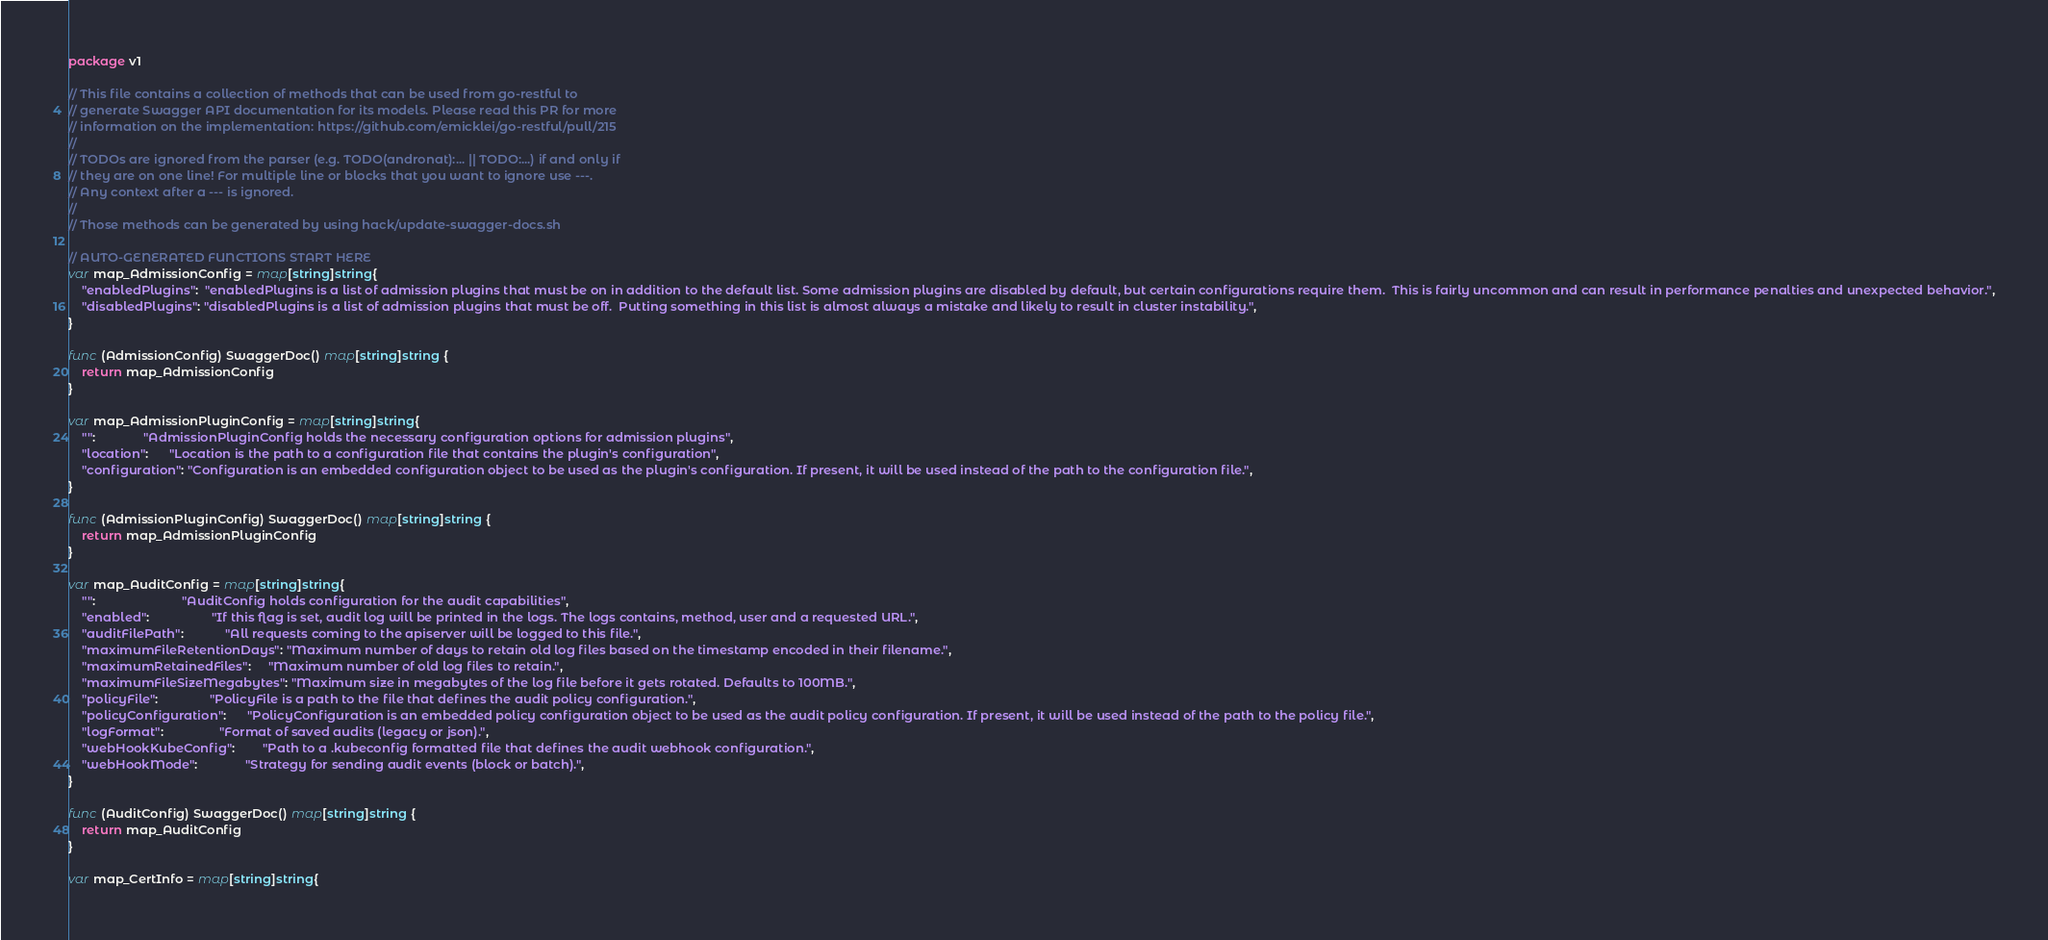<code> <loc_0><loc_0><loc_500><loc_500><_Go_>package v1

// This file contains a collection of methods that can be used from go-restful to
// generate Swagger API documentation for its models. Please read this PR for more
// information on the implementation: https://github.com/emicklei/go-restful/pull/215
//
// TODOs are ignored from the parser (e.g. TODO(andronat):... || TODO:...) if and only if
// they are on one line! For multiple line or blocks that you want to ignore use ---.
// Any context after a --- is ignored.
//
// Those methods can be generated by using hack/update-swagger-docs.sh

// AUTO-GENERATED FUNCTIONS START HERE
var map_AdmissionConfig = map[string]string{
	"enabledPlugins":  "enabledPlugins is a list of admission plugins that must be on in addition to the default list. Some admission plugins are disabled by default, but certain configurations require them.  This is fairly uncommon and can result in performance penalties and unexpected behavior.",
	"disabledPlugins": "disabledPlugins is a list of admission plugins that must be off.  Putting something in this list is almost always a mistake and likely to result in cluster instability.",
}

func (AdmissionConfig) SwaggerDoc() map[string]string {
	return map_AdmissionConfig
}

var map_AdmissionPluginConfig = map[string]string{
	"":              "AdmissionPluginConfig holds the necessary configuration options for admission plugins",
	"location":      "Location is the path to a configuration file that contains the plugin's configuration",
	"configuration": "Configuration is an embedded configuration object to be used as the plugin's configuration. If present, it will be used instead of the path to the configuration file.",
}

func (AdmissionPluginConfig) SwaggerDoc() map[string]string {
	return map_AdmissionPluginConfig
}

var map_AuditConfig = map[string]string{
	"":                         "AuditConfig holds configuration for the audit capabilities",
	"enabled":                  "If this flag is set, audit log will be printed in the logs. The logs contains, method, user and a requested URL.",
	"auditFilePath":            "All requests coming to the apiserver will be logged to this file.",
	"maximumFileRetentionDays": "Maximum number of days to retain old log files based on the timestamp encoded in their filename.",
	"maximumRetainedFiles":     "Maximum number of old log files to retain.",
	"maximumFileSizeMegabytes": "Maximum size in megabytes of the log file before it gets rotated. Defaults to 100MB.",
	"policyFile":               "PolicyFile is a path to the file that defines the audit policy configuration.",
	"policyConfiguration":      "PolicyConfiguration is an embedded policy configuration object to be used as the audit policy configuration. If present, it will be used instead of the path to the policy file.",
	"logFormat":                "Format of saved audits (legacy or json).",
	"webHookKubeConfig":        "Path to a .kubeconfig formatted file that defines the audit webhook configuration.",
	"webHookMode":              "Strategy for sending audit events (block or batch).",
}

func (AuditConfig) SwaggerDoc() map[string]string {
	return map_AuditConfig
}

var map_CertInfo = map[string]string{</code> 